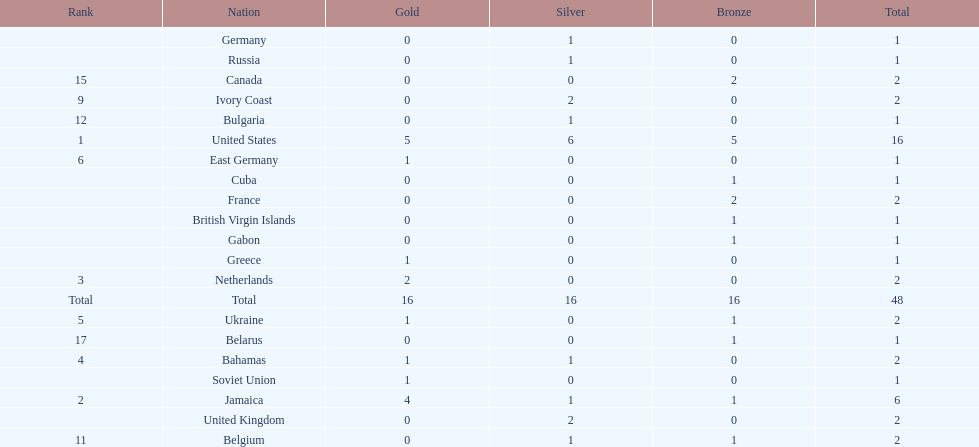Which countries competed in the 60 meters competition? United States, Jamaica, Netherlands, Bahamas, Ukraine, East Germany, Greece, Soviet Union, Ivory Coast, United Kingdom, Belgium, Bulgaria, Russia, Germany, Canada, France, Belarus, Cuba, Gabon, British Virgin Islands. And how many gold medals did they win? 5, 4, 2, 1, 1, 1, 1, 1, 0, 0, 0, 0, 0, 0, 0, 0, 0, 0, 0, 0. Of those countries, which won the second highest number gold medals? Jamaica. 